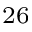Convert formula to latex. <formula><loc_0><loc_0><loc_500><loc_500>^ { 2 6 }</formula> 